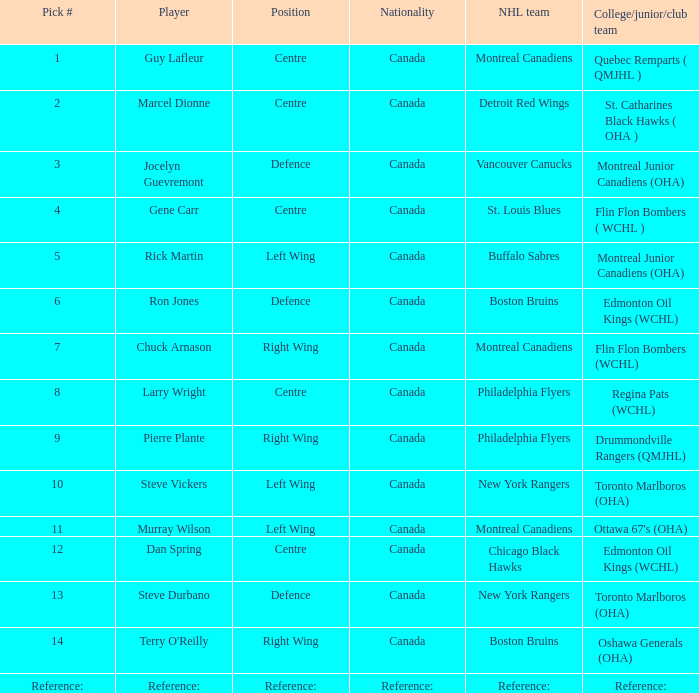Steve durbano is a player for which nhl team? New York Rangers. 